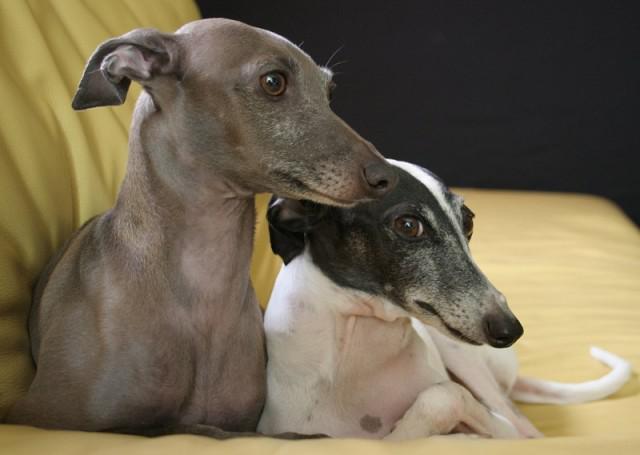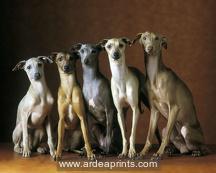The first image is the image on the left, the second image is the image on the right. Examine the images to the left and right. Is the description "Two dogs are sitting together on a piece of furniture in the image on the left." accurate? Answer yes or no. Yes. The first image is the image on the left, the second image is the image on the right. Analyze the images presented: Is the assertion "Each image features a single dog, and one dog looks rightward while the other is facing forward." valid? Answer yes or no. No. 